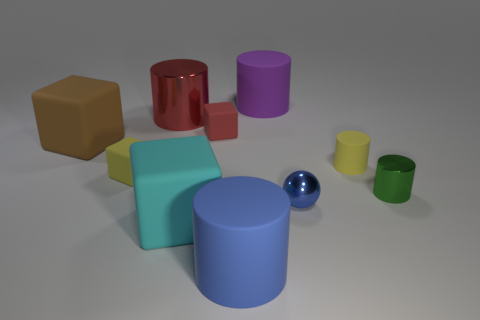Subtract all tiny yellow cylinders. How many cylinders are left? 4 Subtract all red blocks. How many blocks are left? 3 Subtract all spheres. How many objects are left? 9 Subtract 3 cylinders. How many cylinders are left? 2 Subtract all yellow spheres. How many green cylinders are left? 1 Subtract all tiny blue shiny things. Subtract all brown cubes. How many objects are left? 8 Add 3 big cylinders. How many big cylinders are left? 6 Add 3 blue rubber blocks. How many blue rubber blocks exist? 3 Subtract 1 yellow cylinders. How many objects are left? 9 Subtract all brown cubes. Subtract all gray balls. How many cubes are left? 3 